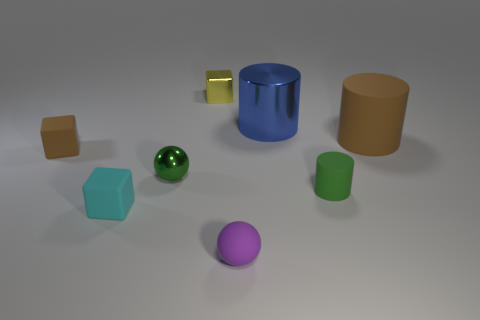Add 1 tiny shiny cubes. How many objects exist? 9 Subtract all balls. How many objects are left? 6 Subtract all small gray blocks. Subtract all blue shiny cylinders. How many objects are left? 7 Add 8 green objects. How many green objects are left? 10 Add 5 tiny brown things. How many tiny brown things exist? 6 Subtract 1 green spheres. How many objects are left? 7 